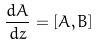Convert formula to latex. <formula><loc_0><loc_0><loc_500><loc_500>\frac { d A } { d z } = [ A , B ]</formula> 